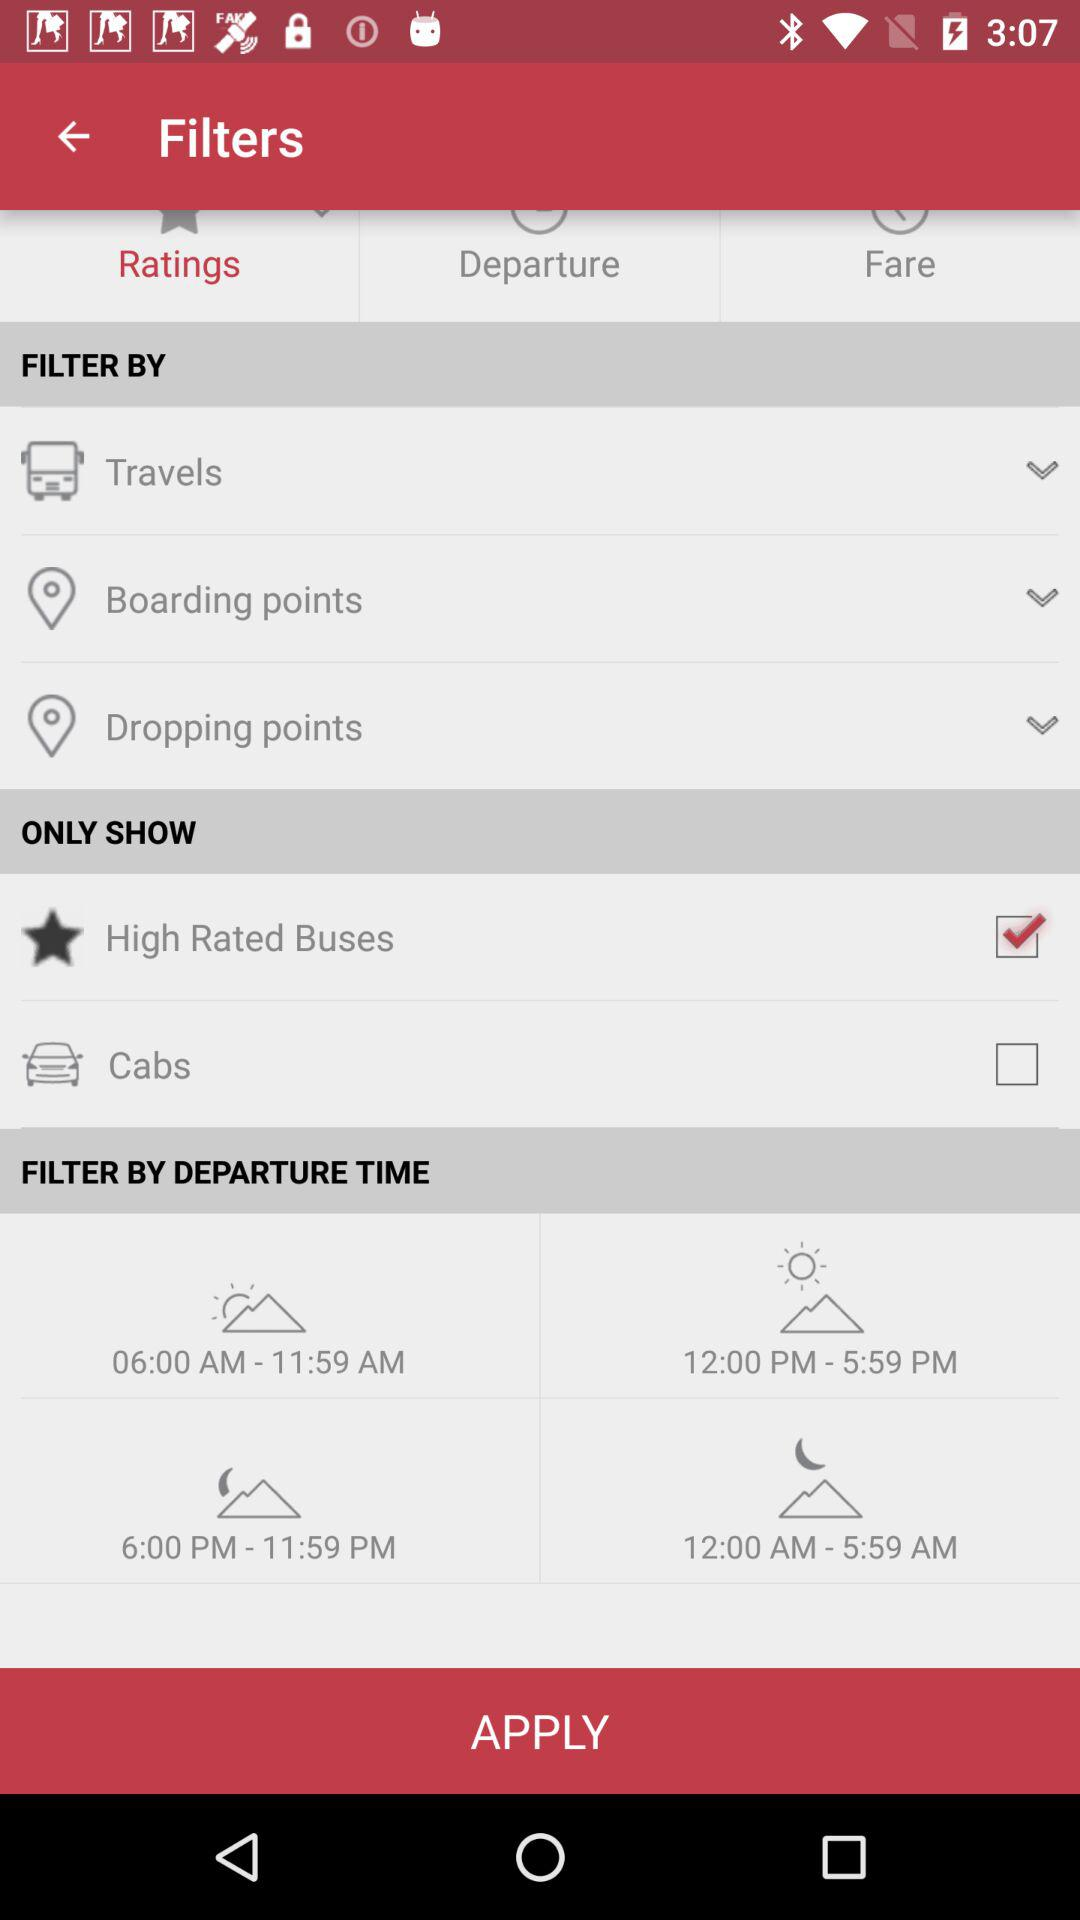What is the current status of the "Cabs"? The status is "off". 